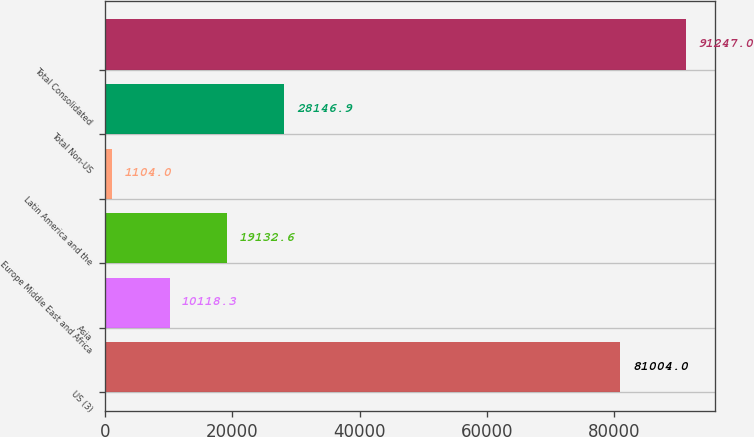Convert chart. <chart><loc_0><loc_0><loc_500><loc_500><bar_chart><fcel>US (3)<fcel>Asia<fcel>Europe Middle East and Africa<fcel>Latin America and the<fcel>Total Non-US<fcel>Total Consolidated<nl><fcel>81004<fcel>10118.3<fcel>19132.6<fcel>1104<fcel>28146.9<fcel>91247<nl></chart> 